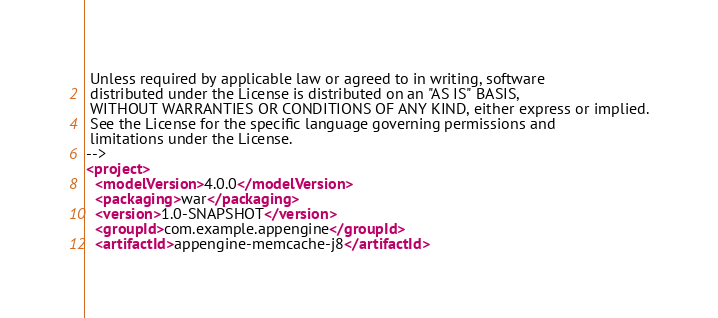Convert code to text. <code><loc_0><loc_0><loc_500><loc_500><_XML_>
 Unless required by applicable law or agreed to in writing, software
 distributed under the License is distributed on an "AS IS" BASIS,
 WITHOUT WARRANTIES OR CONDITIONS OF ANY KIND, either express or implied.
 See the License for the specific language governing permissions and
 limitations under the License.
-->
<project>
  <modelVersion>4.0.0</modelVersion>
  <packaging>war</packaging>
  <version>1.0-SNAPSHOT</version>
  <groupId>com.example.appengine</groupId>
  <artifactId>appengine-memcache-j8</artifactId>
</code> 